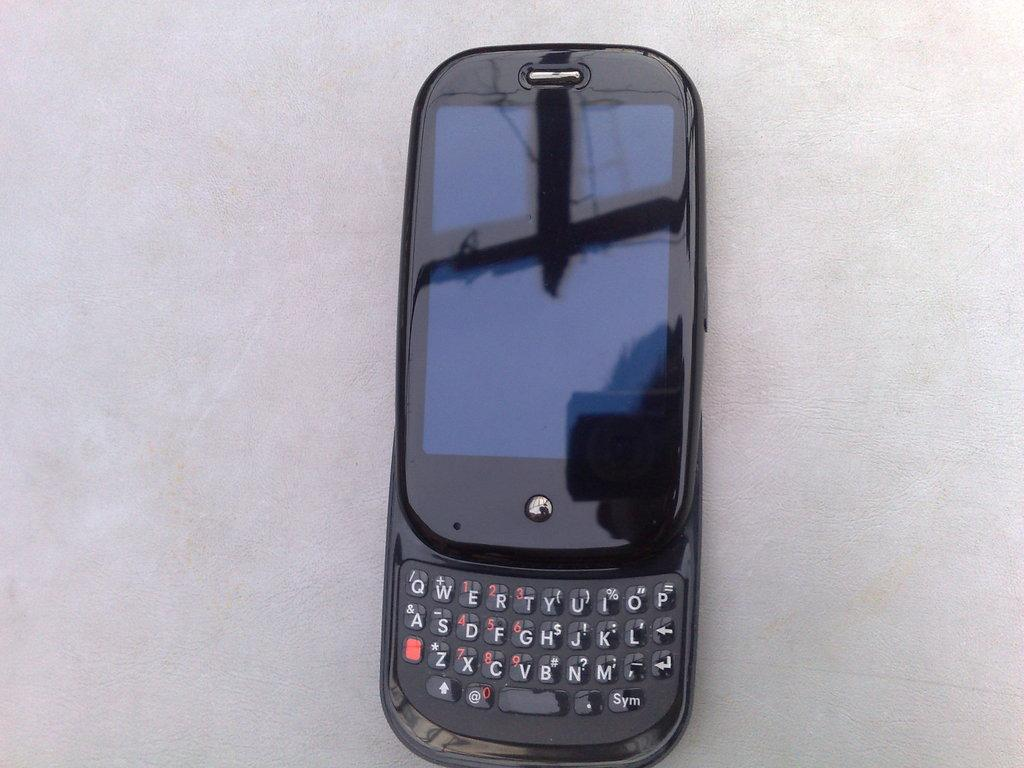What type of device is visible in the image? There is a black mobile phone in the image. Can you describe the color of the mobile phone? The mobile phone is black. What type of horn is attached to the mobile phone in the image? There is no horn attached to the mobile phone in the image. 